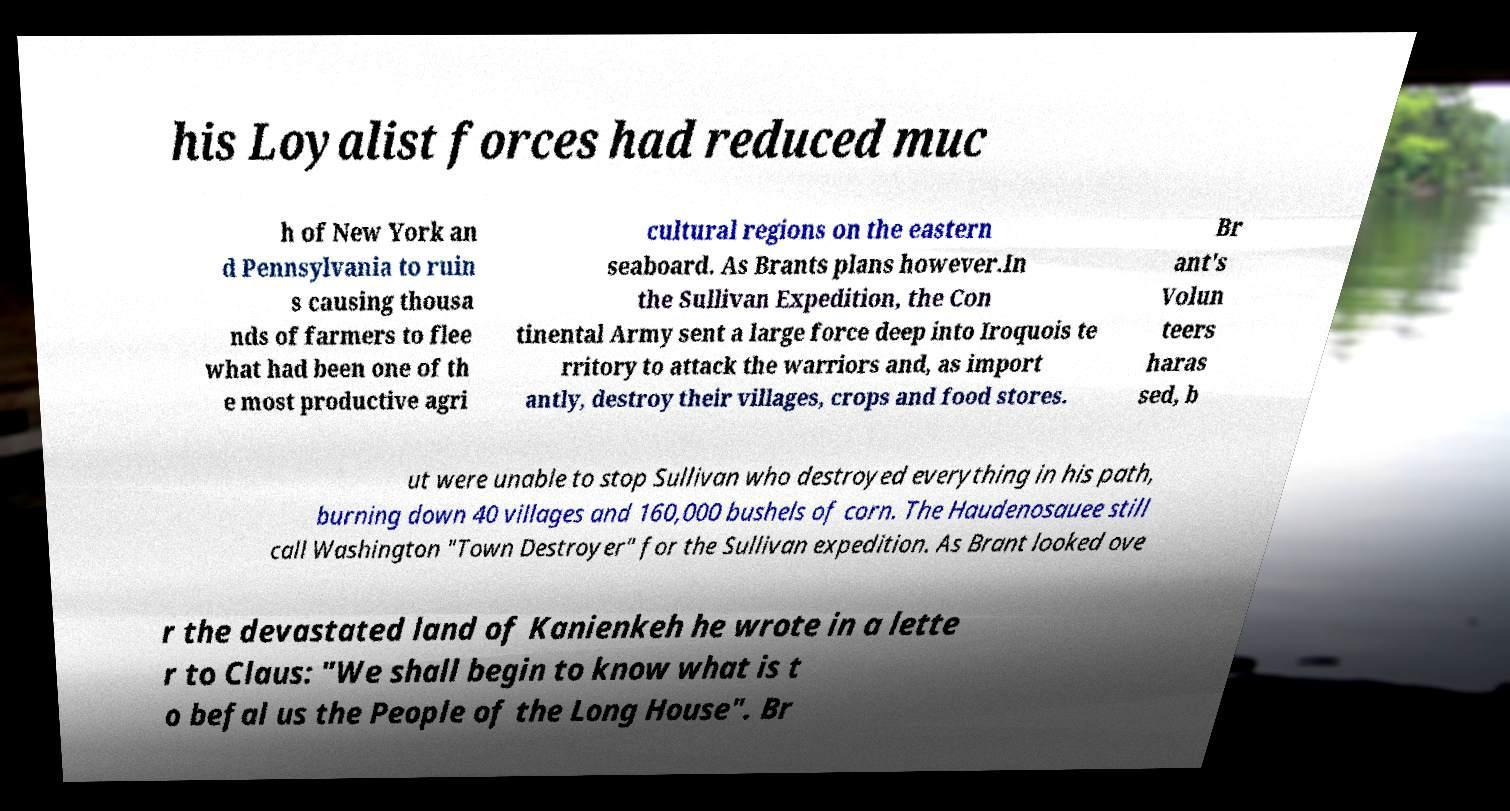Please identify and transcribe the text found in this image. his Loyalist forces had reduced muc h of New York an d Pennsylvania to ruin s causing thousa nds of farmers to flee what had been one of th e most productive agri cultural regions on the eastern seaboard. As Brants plans however.In the Sullivan Expedition, the Con tinental Army sent a large force deep into Iroquois te rritory to attack the warriors and, as import antly, destroy their villages, crops and food stores. Br ant's Volun teers haras sed, b ut were unable to stop Sullivan who destroyed everything in his path, burning down 40 villages and 160,000 bushels of corn. The Haudenosauee still call Washington "Town Destroyer" for the Sullivan expedition. As Brant looked ove r the devastated land of Kanienkeh he wrote in a lette r to Claus: "We shall begin to know what is t o befal us the People of the Long House". Br 